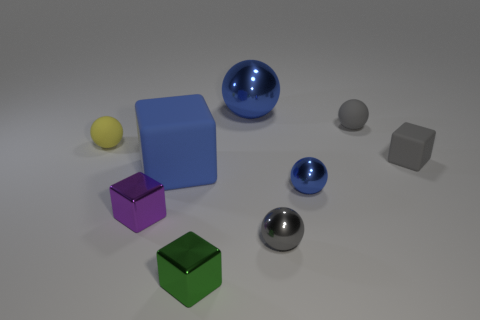Subtract 1 cubes. How many cubes are left? 3 Subtract all tiny yellow rubber balls. How many balls are left? 4 Subtract all brown balls. Subtract all cyan cubes. How many balls are left? 5 Subtract all spheres. How many objects are left? 4 Subtract 1 gray blocks. How many objects are left? 8 Subtract all small shiny blocks. Subtract all small objects. How many objects are left? 0 Add 9 small gray matte balls. How many small gray matte balls are left? 10 Add 2 blue spheres. How many blue spheres exist? 4 